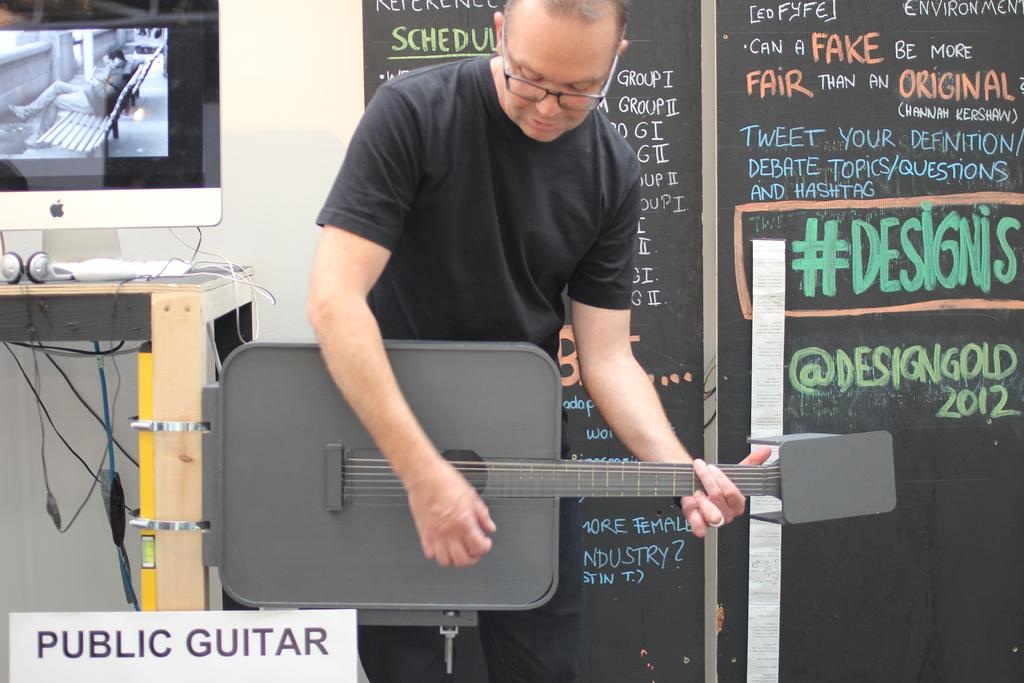What is the main subject of the image? There is a person standing in the center of the image. What is the person doing in the image? The person is playing a guitar. Where is the table located in the image? The table is on the left side of the image. What object is on the table? There is a computer on the table. What type of ornament is hanging from the guitar in the image? There is no ornament hanging from the guitar in the image; the person is simply playing the guitar. 